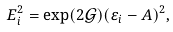Convert formula to latex. <formula><loc_0><loc_0><loc_500><loc_500>E _ { i } ^ { 2 } = \exp ( 2 \mathcal { G ) ( \varepsilon } _ { i } - A ) ^ { 2 } ,</formula> 